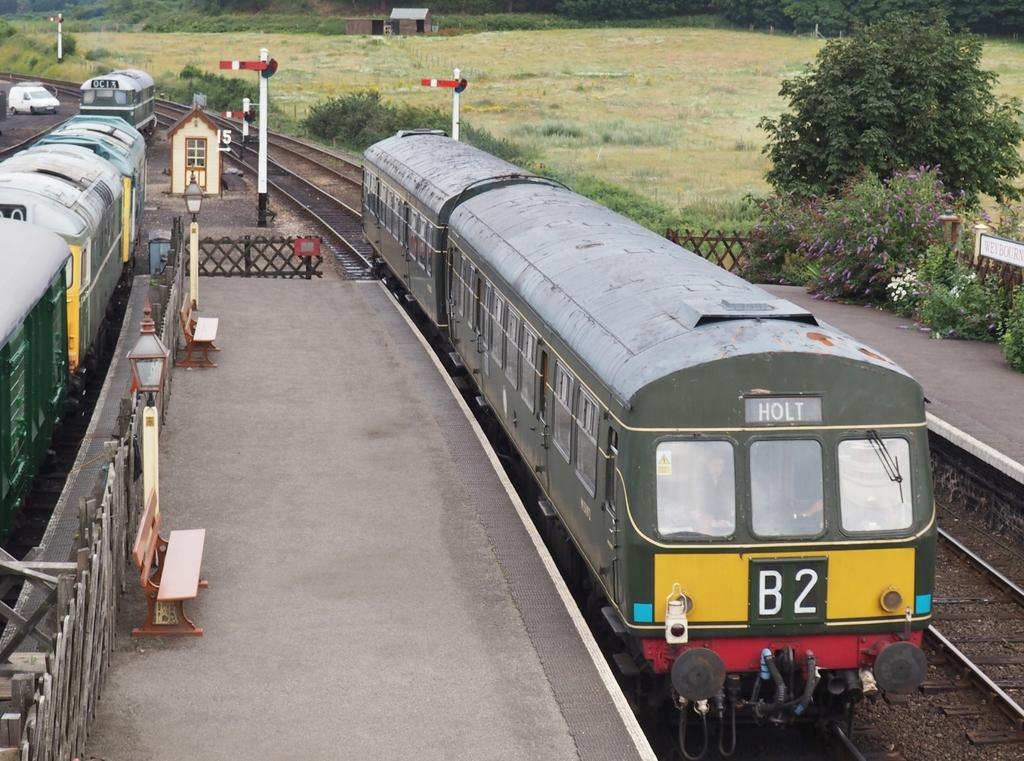<image>
Render a clear and concise summary of the photo. OC13 is the number of the train on the plate 